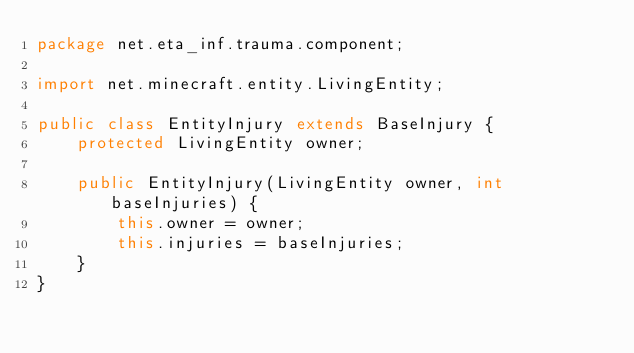<code> <loc_0><loc_0><loc_500><loc_500><_Java_>package net.eta_inf.trauma.component;

import net.minecraft.entity.LivingEntity;

public class EntityInjury extends BaseInjury {
    protected LivingEntity owner;

    public EntityInjury(LivingEntity owner, int baseInjuries) {
        this.owner = owner;
        this.injuries = baseInjuries;
    }
}
</code> 